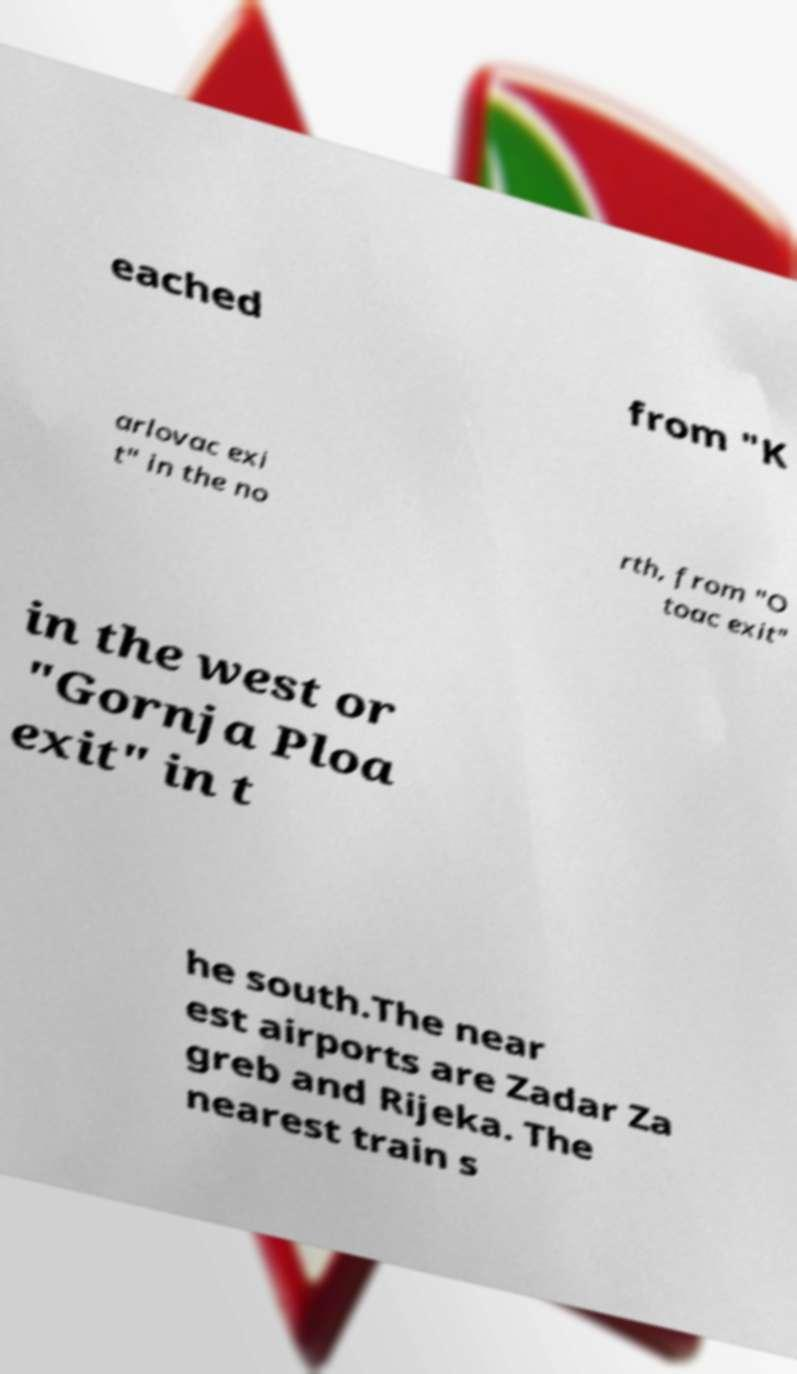I need the written content from this picture converted into text. Can you do that? eached from "K arlovac exi t" in the no rth, from "O toac exit" in the west or "Gornja Ploa exit" in t he south.The near est airports are Zadar Za greb and Rijeka. The nearest train s 